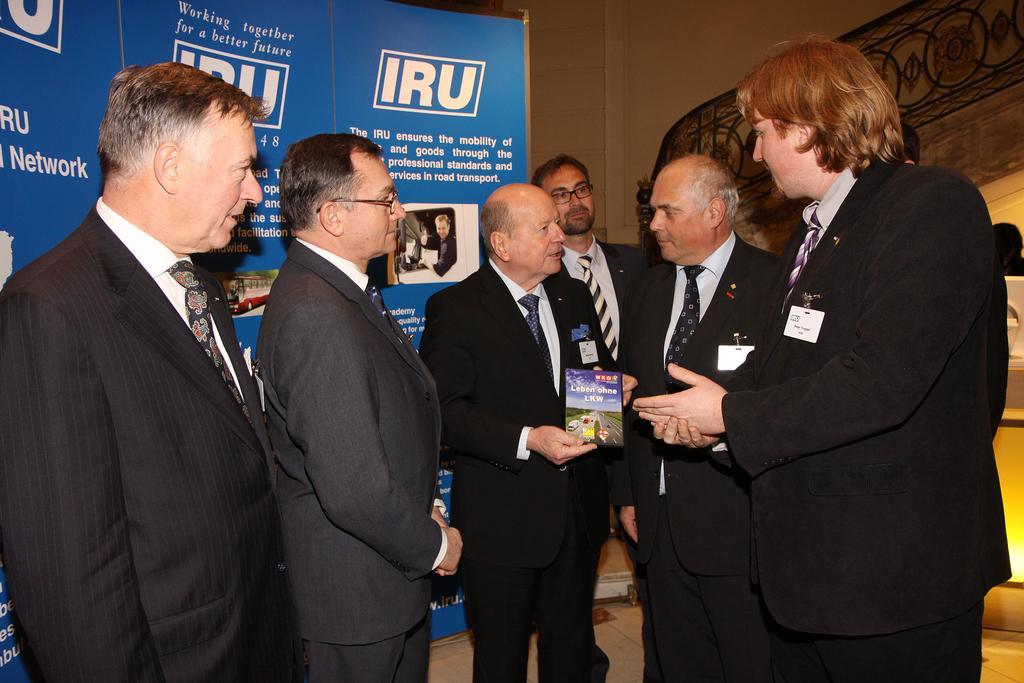Please provide a concise description of this image. In this image we can see a few people standing, among them one is holding an object, behind them there is a poster with some images and text and also we can see the wall. 